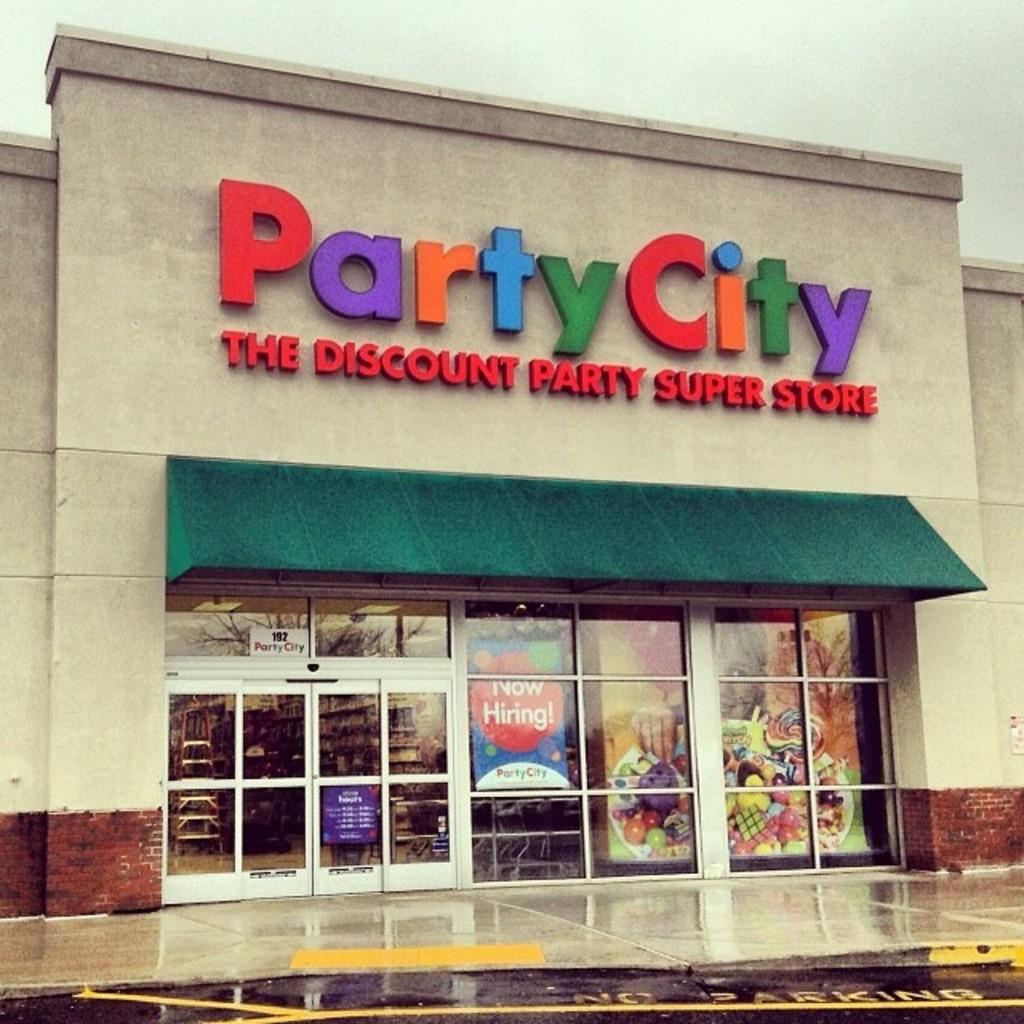What type of structure is visible in the image? There is a building in the image. What feature can be observed on the building? The building has glass windows. Are there any other glass features on the building? Yes, the building has glass doors at the bottom. What is visible in the sky in the image? There are clouds in the sky. Can you hear someone coughing in the image? There is no auditory information provided in the image, so it is impossible to determine if someone is coughing. 